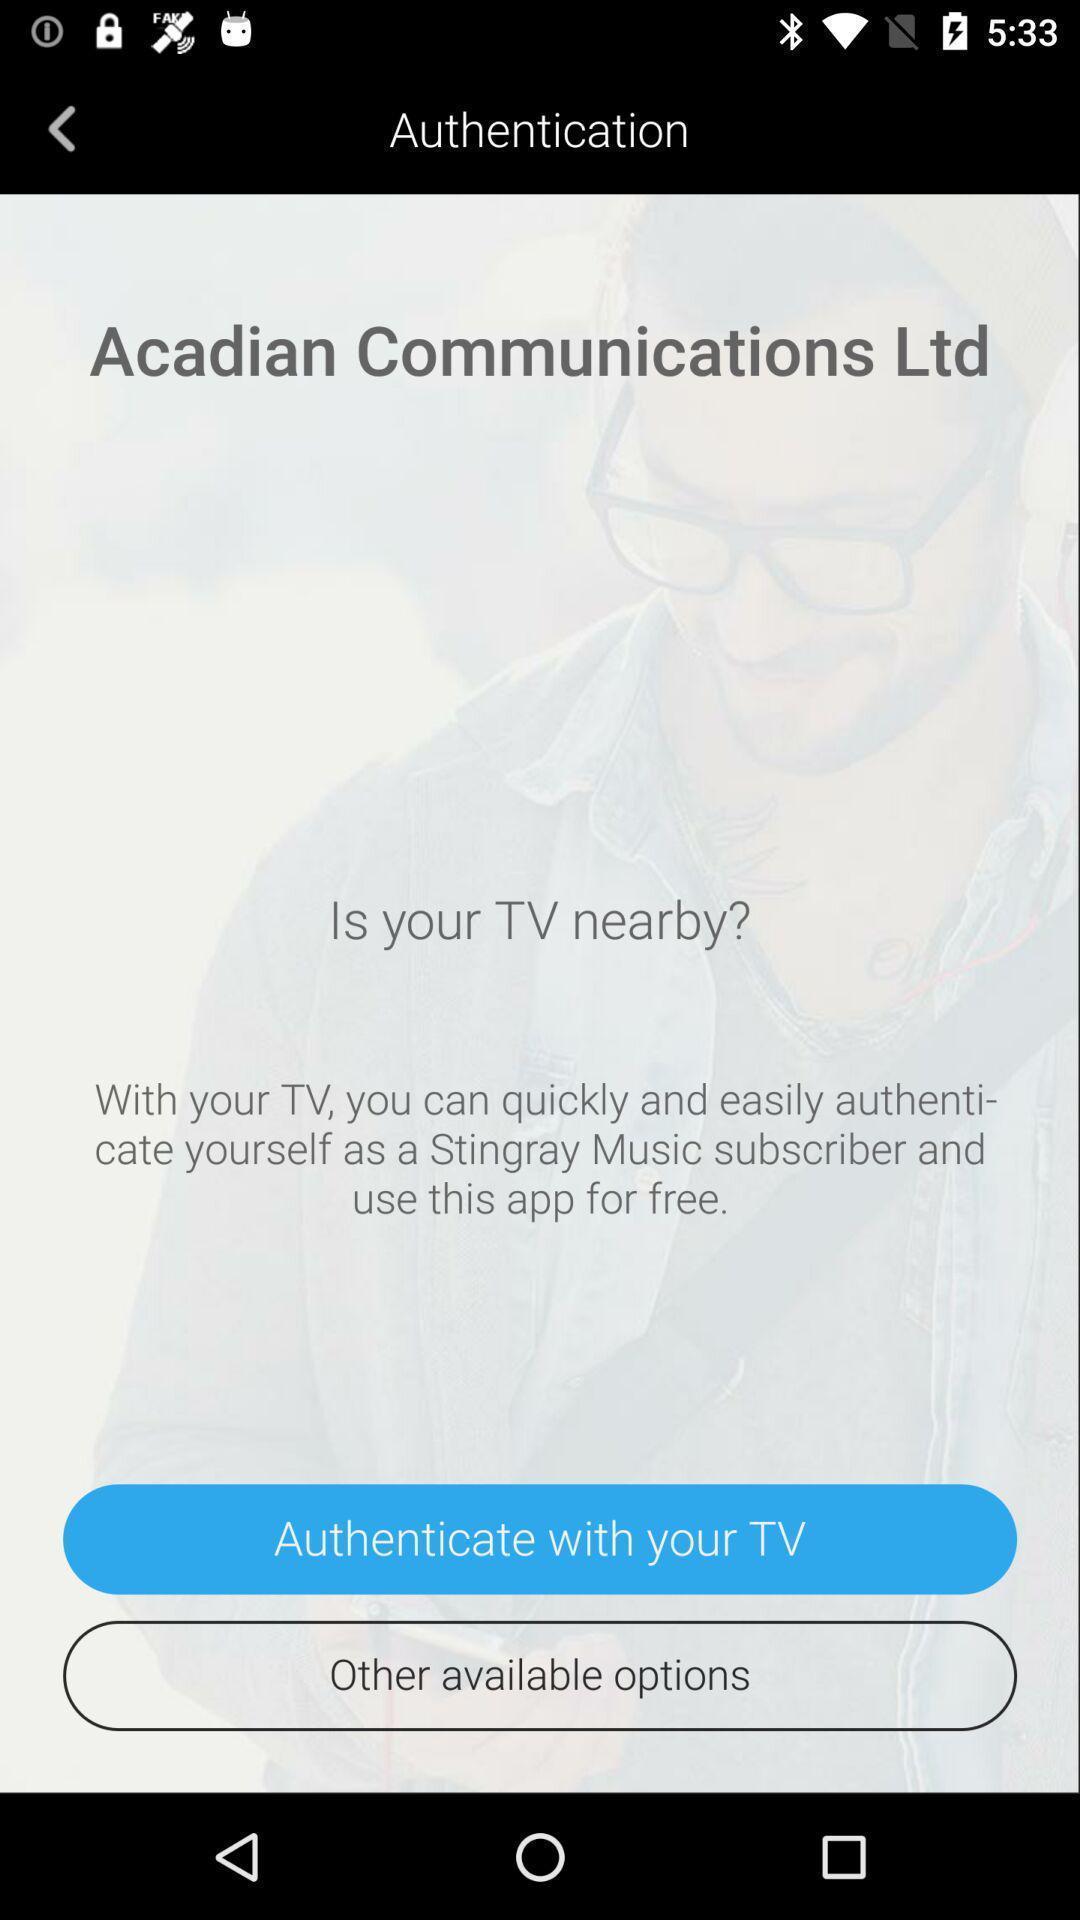What is the overall content of this screenshot? Page displaying use application for free. 